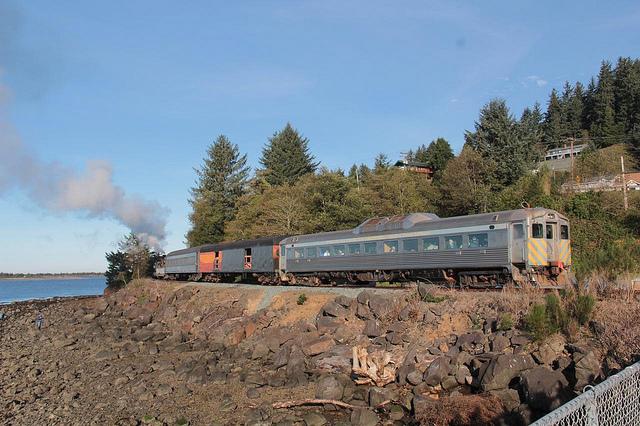What kind of train is this?
Write a very short answer. Passenger. What body of water is in the background?
Be succinct. Lake. What color is the train?
Quick response, please. Gray. Is this a newer train?
Give a very brief answer. No. Is this a modern choo choo?
Short answer required. Yes. Are all of the train cars passenger cars?
Keep it brief. Yes. Are the train tracks on a cliff?
Keep it brief. Yes. What type of train engine is this?
Write a very short answer. Steam. 